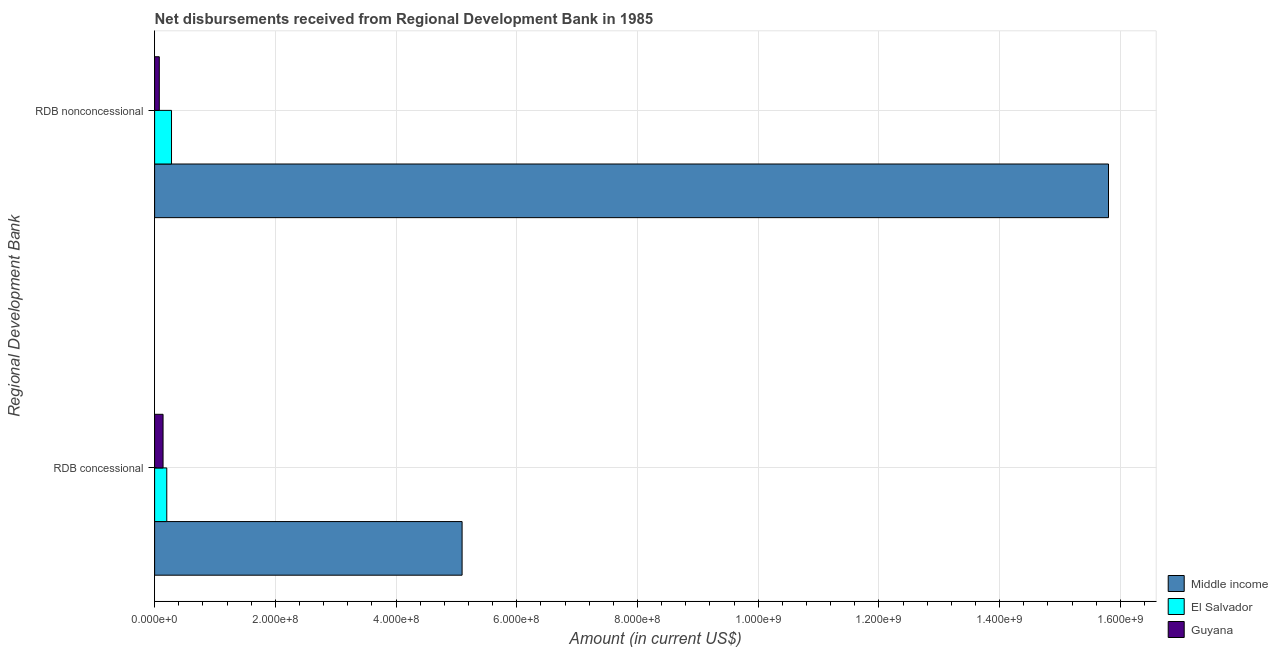Are the number of bars on each tick of the Y-axis equal?
Provide a short and direct response. Yes. How many bars are there on the 2nd tick from the top?
Give a very brief answer. 3. What is the label of the 1st group of bars from the top?
Make the answer very short. RDB nonconcessional. What is the net concessional disbursements from rdb in Guyana?
Ensure brevity in your answer.  1.40e+07. Across all countries, what is the maximum net non concessional disbursements from rdb?
Offer a terse response. 1.58e+09. Across all countries, what is the minimum net non concessional disbursements from rdb?
Offer a terse response. 7.76e+06. In which country was the net non concessional disbursements from rdb minimum?
Provide a short and direct response. Guyana. What is the total net concessional disbursements from rdb in the graph?
Ensure brevity in your answer.  5.44e+08. What is the difference between the net concessional disbursements from rdb in Guyana and that in El Salvador?
Your response must be concise. -6.16e+06. What is the difference between the net concessional disbursements from rdb in El Salvador and the net non concessional disbursements from rdb in Guyana?
Your answer should be compact. 1.24e+07. What is the average net non concessional disbursements from rdb per country?
Keep it short and to the point. 5.39e+08. What is the difference between the net concessional disbursements from rdb and net non concessional disbursements from rdb in Guyana?
Your response must be concise. 6.25e+06. What is the ratio of the net concessional disbursements from rdb in Middle income to that in Guyana?
Keep it short and to the point. 36.36. What does the 3rd bar from the bottom in RDB nonconcessional represents?
Provide a short and direct response. Guyana. Are all the bars in the graph horizontal?
Your response must be concise. Yes. What is the difference between two consecutive major ticks on the X-axis?
Give a very brief answer. 2.00e+08. Are the values on the major ticks of X-axis written in scientific E-notation?
Offer a very short reply. Yes. Does the graph contain any zero values?
Provide a succinct answer. No. Does the graph contain grids?
Give a very brief answer. Yes. Where does the legend appear in the graph?
Ensure brevity in your answer.  Bottom right. How are the legend labels stacked?
Offer a terse response. Vertical. What is the title of the graph?
Keep it short and to the point. Net disbursements received from Regional Development Bank in 1985. Does "Botswana" appear as one of the legend labels in the graph?
Offer a terse response. No. What is the label or title of the Y-axis?
Ensure brevity in your answer.  Regional Development Bank. What is the Amount (in current US$) of Middle income in RDB concessional?
Your answer should be very brief. 5.09e+08. What is the Amount (in current US$) of El Salvador in RDB concessional?
Provide a succinct answer. 2.02e+07. What is the Amount (in current US$) of Guyana in RDB concessional?
Provide a short and direct response. 1.40e+07. What is the Amount (in current US$) in Middle income in RDB nonconcessional?
Offer a very short reply. 1.58e+09. What is the Amount (in current US$) of El Salvador in RDB nonconcessional?
Your answer should be compact. 2.80e+07. What is the Amount (in current US$) in Guyana in RDB nonconcessional?
Offer a terse response. 7.76e+06. Across all Regional Development Bank, what is the maximum Amount (in current US$) of Middle income?
Offer a very short reply. 1.58e+09. Across all Regional Development Bank, what is the maximum Amount (in current US$) in El Salvador?
Your response must be concise. 2.80e+07. Across all Regional Development Bank, what is the maximum Amount (in current US$) of Guyana?
Make the answer very short. 1.40e+07. Across all Regional Development Bank, what is the minimum Amount (in current US$) of Middle income?
Your answer should be very brief. 5.09e+08. Across all Regional Development Bank, what is the minimum Amount (in current US$) in El Salvador?
Your answer should be very brief. 2.02e+07. Across all Regional Development Bank, what is the minimum Amount (in current US$) in Guyana?
Your answer should be compact. 7.76e+06. What is the total Amount (in current US$) in Middle income in the graph?
Ensure brevity in your answer.  2.09e+09. What is the total Amount (in current US$) of El Salvador in the graph?
Your answer should be compact. 4.82e+07. What is the total Amount (in current US$) in Guyana in the graph?
Your response must be concise. 2.18e+07. What is the difference between the Amount (in current US$) of Middle income in RDB concessional and that in RDB nonconcessional?
Give a very brief answer. -1.07e+09. What is the difference between the Amount (in current US$) in El Salvador in RDB concessional and that in RDB nonconcessional?
Your response must be concise. -7.83e+06. What is the difference between the Amount (in current US$) in Guyana in RDB concessional and that in RDB nonconcessional?
Make the answer very short. 6.25e+06. What is the difference between the Amount (in current US$) of Middle income in RDB concessional and the Amount (in current US$) of El Salvador in RDB nonconcessional?
Offer a very short reply. 4.81e+08. What is the difference between the Amount (in current US$) in Middle income in RDB concessional and the Amount (in current US$) in Guyana in RDB nonconcessional?
Make the answer very short. 5.02e+08. What is the difference between the Amount (in current US$) of El Salvador in RDB concessional and the Amount (in current US$) of Guyana in RDB nonconcessional?
Ensure brevity in your answer.  1.24e+07. What is the average Amount (in current US$) in Middle income per Regional Development Bank?
Provide a succinct answer. 1.04e+09. What is the average Amount (in current US$) of El Salvador per Regional Development Bank?
Ensure brevity in your answer.  2.41e+07. What is the average Amount (in current US$) in Guyana per Regional Development Bank?
Provide a short and direct response. 1.09e+07. What is the difference between the Amount (in current US$) of Middle income and Amount (in current US$) of El Salvador in RDB concessional?
Keep it short and to the point. 4.89e+08. What is the difference between the Amount (in current US$) of Middle income and Amount (in current US$) of Guyana in RDB concessional?
Give a very brief answer. 4.95e+08. What is the difference between the Amount (in current US$) in El Salvador and Amount (in current US$) in Guyana in RDB concessional?
Provide a succinct answer. 6.16e+06. What is the difference between the Amount (in current US$) in Middle income and Amount (in current US$) in El Salvador in RDB nonconcessional?
Keep it short and to the point. 1.55e+09. What is the difference between the Amount (in current US$) in Middle income and Amount (in current US$) in Guyana in RDB nonconcessional?
Your answer should be compact. 1.57e+09. What is the difference between the Amount (in current US$) of El Salvador and Amount (in current US$) of Guyana in RDB nonconcessional?
Ensure brevity in your answer.  2.02e+07. What is the ratio of the Amount (in current US$) of Middle income in RDB concessional to that in RDB nonconcessional?
Your answer should be very brief. 0.32. What is the ratio of the Amount (in current US$) of El Salvador in RDB concessional to that in RDB nonconcessional?
Your answer should be compact. 0.72. What is the ratio of the Amount (in current US$) of Guyana in RDB concessional to that in RDB nonconcessional?
Your answer should be compact. 1.8. What is the difference between the highest and the second highest Amount (in current US$) of Middle income?
Keep it short and to the point. 1.07e+09. What is the difference between the highest and the second highest Amount (in current US$) in El Salvador?
Keep it short and to the point. 7.83e+06. What is the difference between the highest and the second highest Amount (in current US$) in Guyana?
Provide a succinct answer. 6.25e+06. What is the difference between the highest and the lowest Amount (in current US$) of Middle income?
Ensure brevity in your answer.  1.07e+09. What is the difference between the highest and the lowest Amount (in current US$) of El Salvador?
Provide a short and direct response. 7.83e+06. What is the difference between the highest and the lowest Amount (in current US$) of Guyana?
Provide a short and direct response. 6.25e+06. 